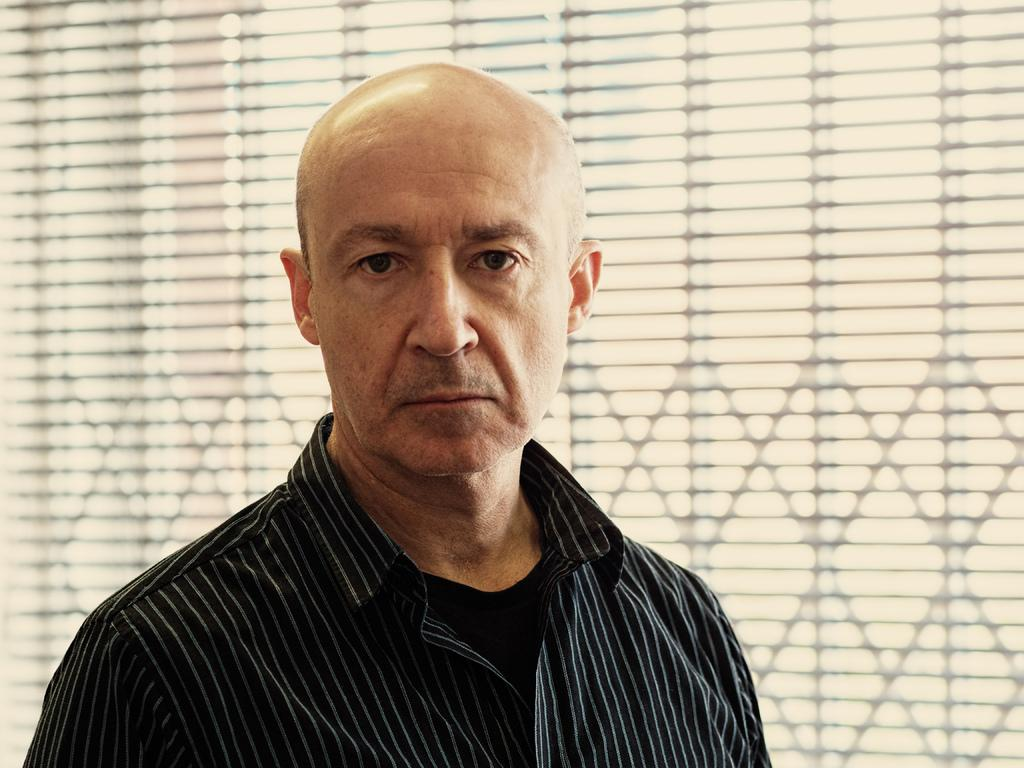Who or what is the main subject in the center of the image? There is a person in the center of the image. What can be seen in the background of the image? There is a window in the background of the image. What type of snail is crawling on the person's shoulder in the image? There is no snail present on the person's shoulder in the image. What selection process is being depicted in the image? The image does not depict a selection process; it features a person and a window in the background. 